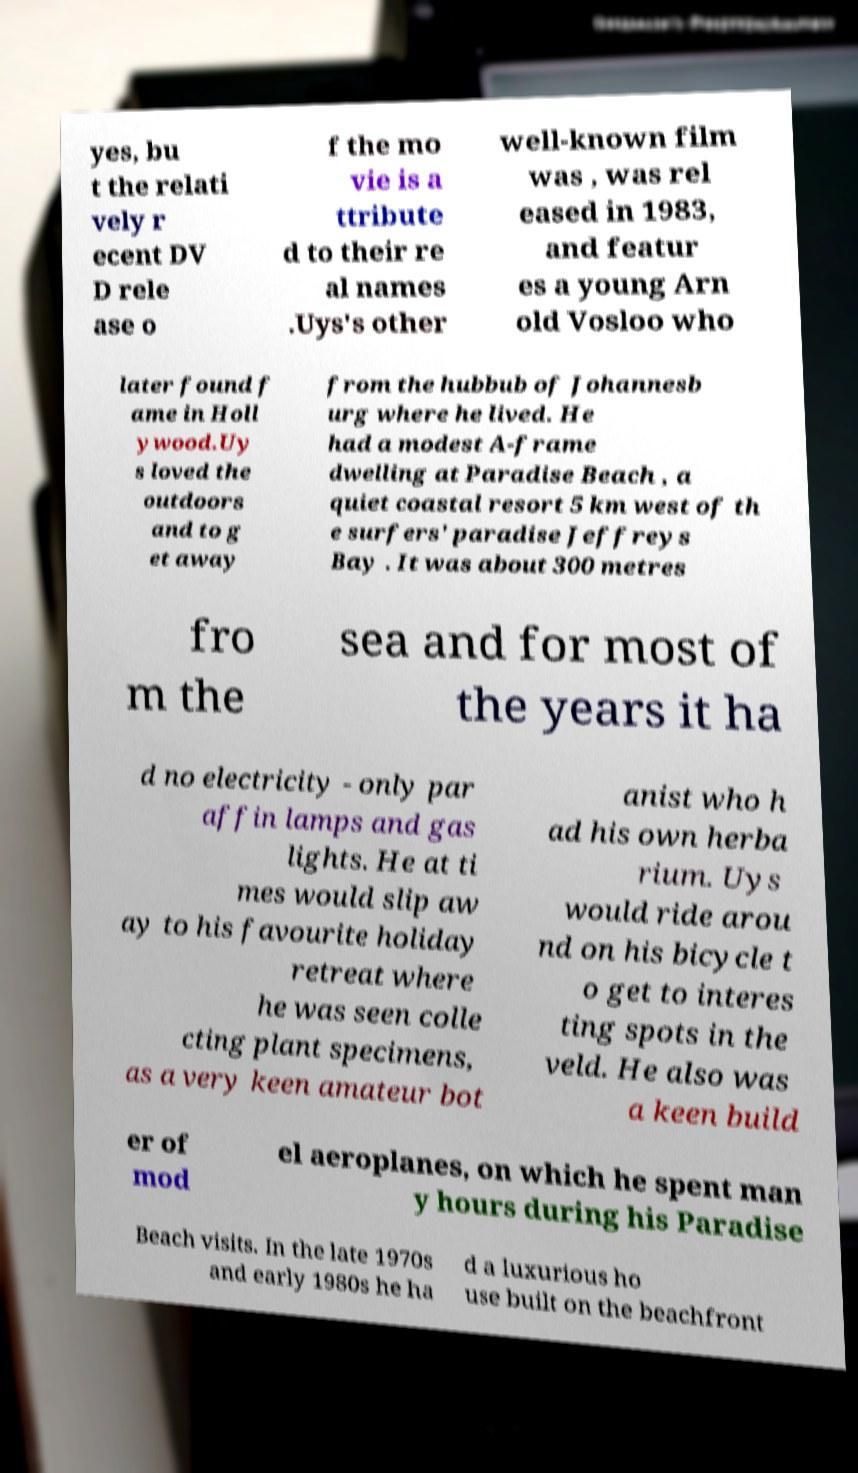Could you assist in decoding the text presented in this image and type it out clearly? yes, bu t the relati vely r ecent DV D rele ase o f the mo vie is a ttribute d to their re al names .Uys's other well-known film was , was rel eased in 1983, and featur es a young Arn old Vosloo who later found f ame in Holl ywood.Uy s loved the outdoors and to g et away from the hubbub of Johannesb urg where he lived. He had a modest A-frame dwelling at Paradise Beach , a quiet coastal resort 5 km west of th e surfers' paradise Jeffreys Bay . It was about 300 metres fro m the sea and for most of the years it ha d no electricity - only par affin lamps and gas lights. He at ti mes would slip aw ay to his favourite holiday retreat where he was seen colle cting plant specimens, as a very keen amateur bot anist who h ad his own herba rium. Uys would ride arou nd on his bicycle t o get to interes ting spots in the veld. He also was a keen build er of mod el aeroplanes, on which he spent man y hours during his Paradise Beach visits. In the late 1970s and early 1980s he ha d a luxurious ho use built on the beachfront 